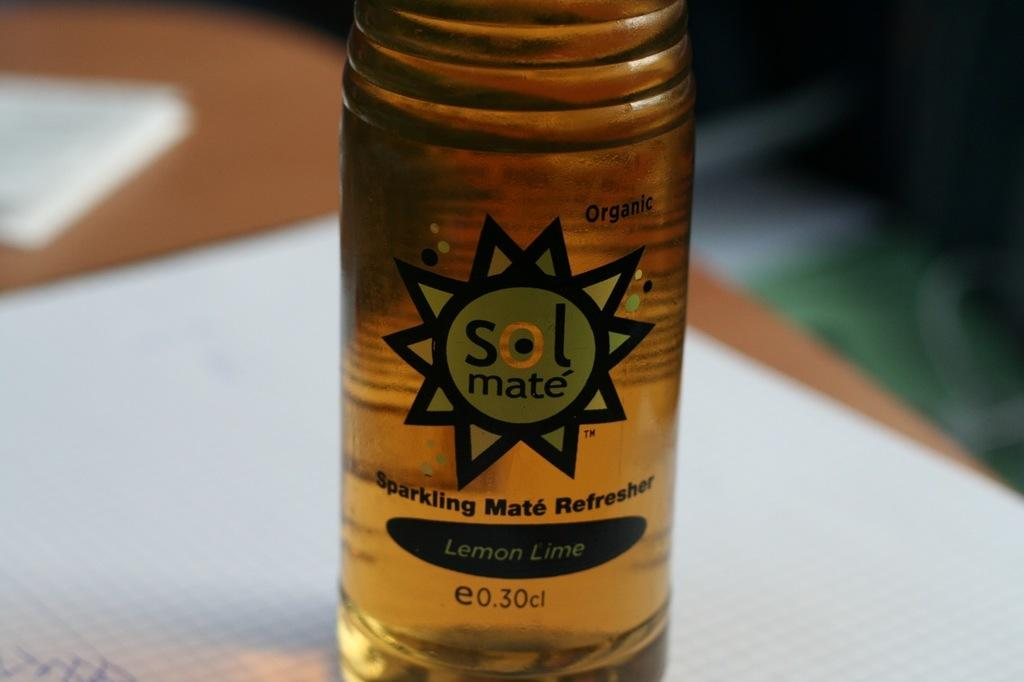<image>
Present a compact description of the photo's key features. A sparkling drink has a sol mate logo on the front. 